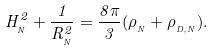<formula> <loc_0><loc_0><loc_500><loc_500>H ^ { 2 } _ { _ { N } } + \frac { 1 } { R ^ { 2 } _ { _ { N } } } = \frac { 8 \pi } { 3 } ( \rho _ { _ { N } } + \rho _ { _ { D , N } } ) .</formula> 